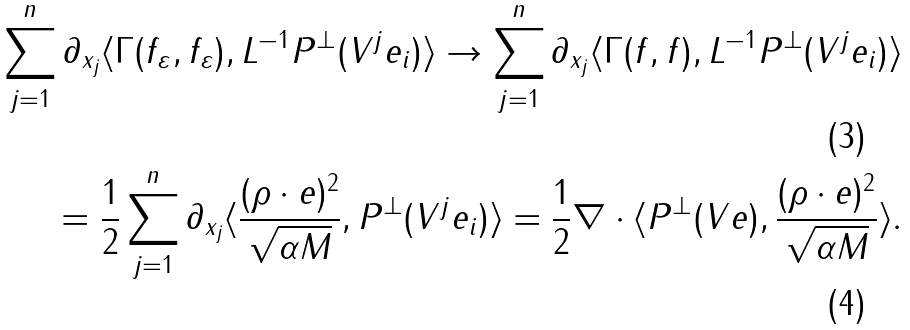<formula> <loc_0><loc_0><loc_500><loc_500>\sum _ { j = 1 } ^ { n } \partial _ { x _ { j } } \langle \Gamma ( f _ { \varepsilon } , f _ { \varepsilon } ) , L ^ { - 1 } P ^ { \perp } ( V ^ { j } e _ { i } ) \rangle \to \sum _ { j = 1 } ^ { n } \partial _ { x _ { j } } \langle \Gamma ( f , f ) , L ^ { - 1 } P ^ { \perp } ( V ^ { j } e _ { i } ) \rangle \\ = \frac { 1 } { 2 } \sum _ { j = 1 } ^ { n } \partial _ { x _ { j } } \langle \frac { ( \rho \cdot e ) ^ { 2 } } { \sqrt { \alpha M } } , P ^ { \perp } ( V ^ { j } e _ { i } ) \rangle = \frac { 1 } { 2 } \nabla \cdot \langle P ^ { \perp } ( V e ) , \frac { ( \rho \cdot e ) ^ { 2 } } { \sqrt { \alpha M } } \rangle .</formula> 